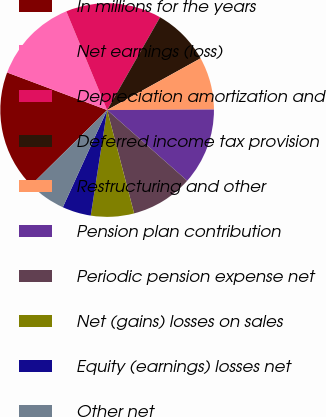Convert chart to OTSL. <chart><loc_0><loc_0><loc_500><loc_500><pie_chart><fcel>In millions for the years<fcel>Net earnings (loss)<fcel>Depreciation amortization and<fcel>Deferred income tax provision<fcel>Restructuring and other<fcel>Pension plan contribution<fcel>Periodic pension expense net<fcel>Net (gains) losses on sales<fcel>Equity (earnings) losses net<fcel>Other net<nl><fcel>18.11%<fcel>13.04%<fcel>14.49%<fcel>8.7%<fcel>7.97%<fcel>11.59%<fcel>9.42%<fcel>6.52%<fcel>4.35%<fcel>5.8%<nl></chart> 